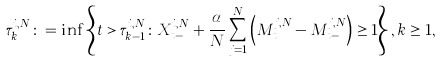Convert formula to latex. <formula><loc_0><loc_0><loc_500><loc_500>\tau _ { k } ^ { i , N } \colon = \inf \left \{ t > \tau _ { k - 1 } ^ { i , N } \colon X _ { t - } ^ { i , N } + \frac { \alpha } { N } \sum _ { j = 1 } ^ { N } \left ( M ^ { j , N } _ { t } - M ^ { j , N } _ { t - } \right ) \geq 1 \right \} , k \geq 1 ,</formula> 